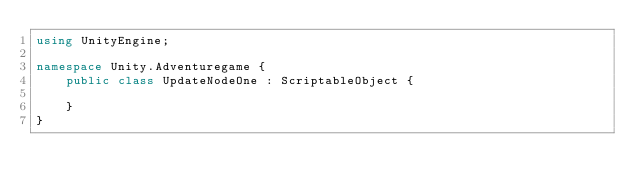Convert code to text. <code><loc_0><loc_0><loc_500><loc_500><_C#_>using UnityEngine;

namespace Unity.Adventuregame {
    public class UpdateNodeOne : ScriptableObject {
        
    }
}</code> 